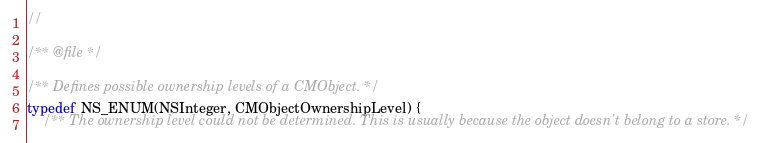Convert code to text. <code><loc_0><loc_0><loc_500><loc_500><_C_>//

/** @file */

/** Defines possible ownership levels of a CMObject. */
typedef NS_ENUM(NSInteger, CMObjectOwnershipLevel) {
    /** The ownership level could not be determined. This is usually because the object doesn't belong to a store. */</code> 